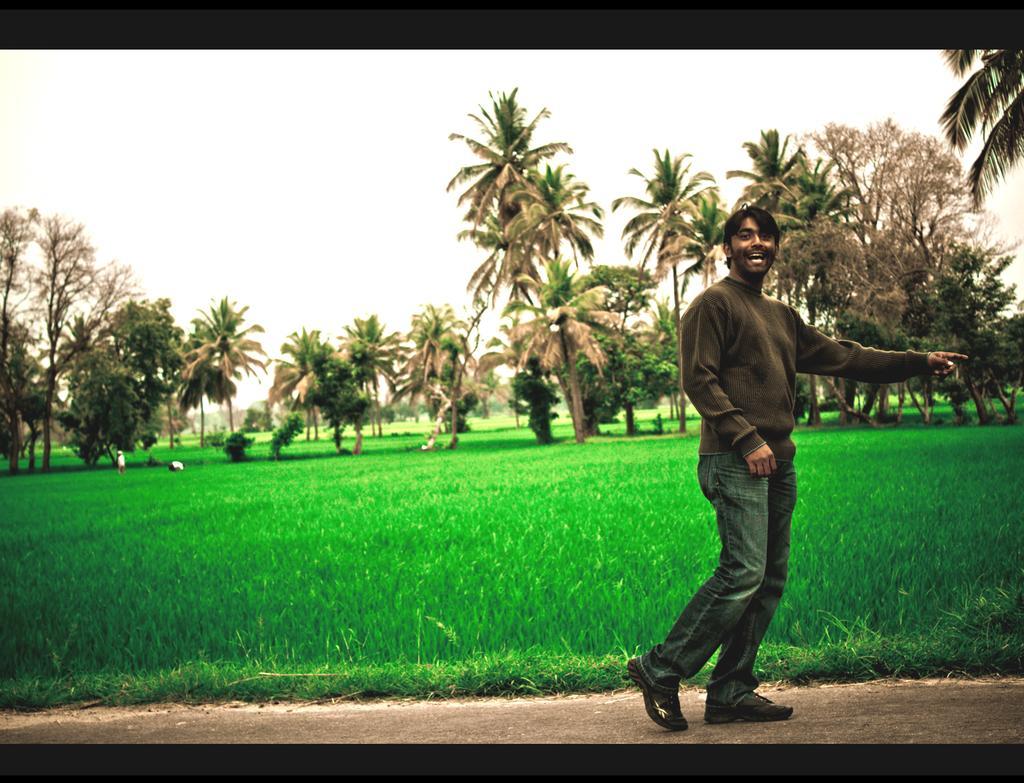Describe this image in one or two sentences. In this image there is a man walking on the path. In the background there is grass and also many trees. Sky is also visible. Image has two black borders. 